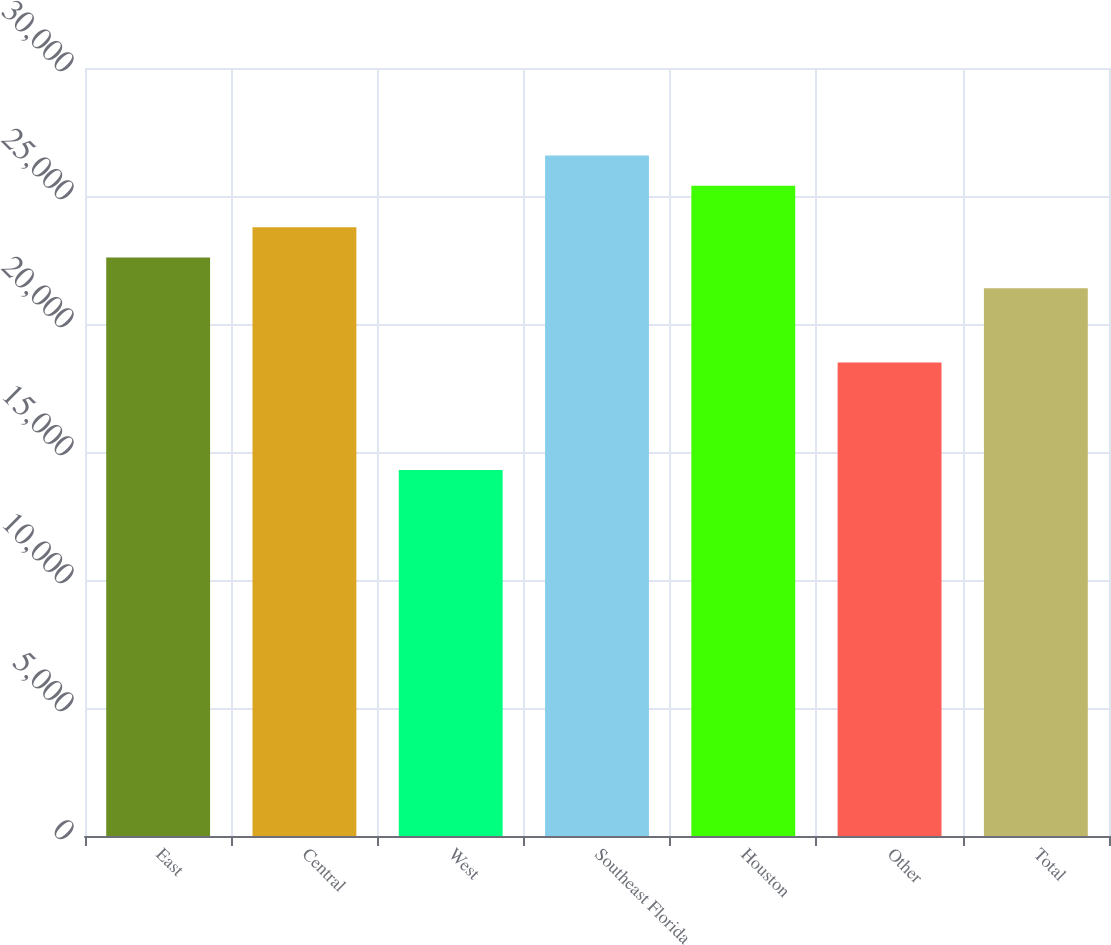<chart> <loc_0><loc_0><loc_500><loc_500><bar_chart><fcel>East<fcel>Central<fcel>West<fcel>Southeast Florida<fcel>Houston<fcel>Other<fcel>Total<nl><fcel>22600<fcel>23780<fcel>14300<fcel>26580<fcel>25400<fcel>18500<fcel>21400<nl></chart> 